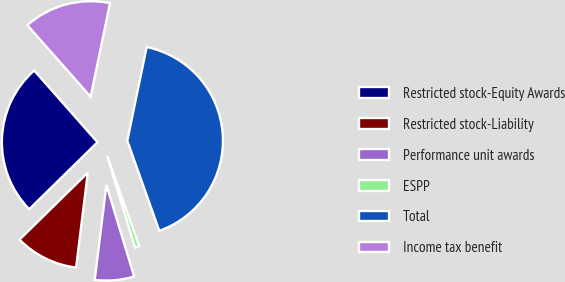<chart> <loc_0><loc_0><loc_500><loc_500><pie_chart><fcel>Restricted stock-Equity Awards<fcel>Restricted stock-Liability<fcel>Performance unit awards<fcel>ESPP<fcel>Total<fcel>Income tax benefit<nl><fcel>25.83%<fcel>10.7%<fcel>6.64%<fcel>0.74%<fcel>41.33%<fcel>14.76%<nl></chart> 